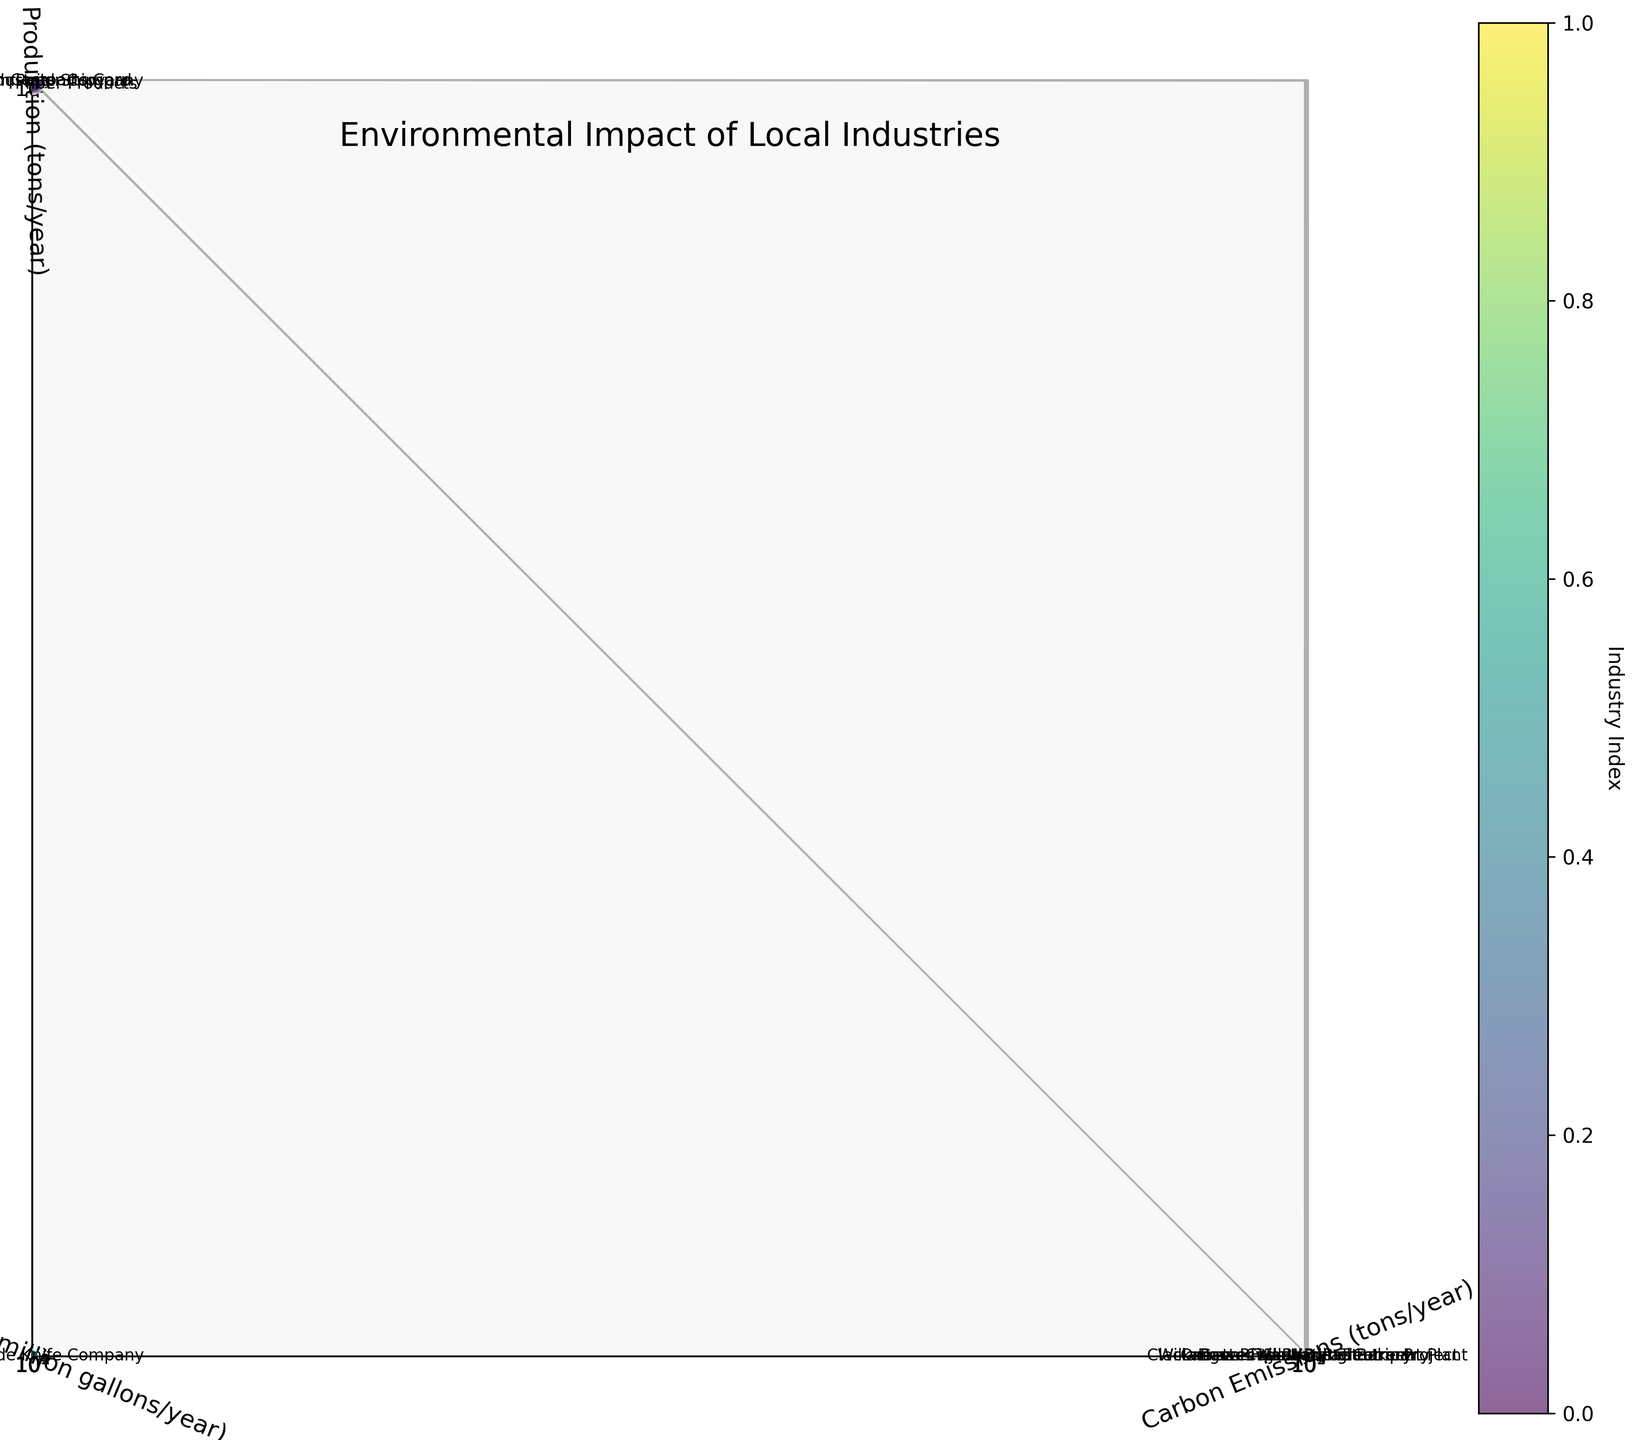What's the title of the figure? The title is typically displayed at the top of the chart. In this case, it is labeled "Environmental Impact of Local Industries," as specified in the code.
Answer: Environmental Impact of Local Industries Which industry has the highest carbon emissions? By examining the x-axis, which represents carbon emissions, and looking for the furthest point to the right, you can identify the industry with the highest carbon emissions. Precision Castparts Corp is found to be the farthest on the x-axis.
Answer: Precision Castparts Corp Which industry uses the most water? By inspecting the y-axis, which represents water usage, and identifying the data point that is highest up along this axis, the label 'Willamette Falls Hydroelectric Project' appears at the highest point.
Answer: Willamette Falls Hydroelectric Project Which industry produces the least waste? To find the industry with the least waste, check the z-axis, representing waste production, and identify the point closest to the bottom. The 'Carver Hangar Restaurant' is the closest to the bottom.
Answer: Carver Hangar Restaurant Which industry has the largest bubble size in the chart? Bubble size in the chart is proportional to (carbon emissions + waste production) / 1000. Visual inspection shows that 'Precision Castparts Corp' has the largest bubble.
Answer: Precision Castparts Corp Compare the water usage between Blue Heron Paper Company and Vigor Industrial Shipyard. Which uses more? Check the y-axis values corresponding to Blue Heron Paper Company and Vigor Industrial Shipyard and compare them. Blue Heron Paper Company uses 1200 million gallons/year, while Vigor Industrial Shipyard uses 600 million gallons/year. Thus, Blue Heron Paper Company uses more water.
Answer: Blue Heron Paper Company How does the carbon emission of Dave's Killer Bread Bakery compare to Estacada Timber Products? Find the points for Dave's Killer Bread Bakery and Estacada Timber Products on the x-axis and compare. Dave's Killer Bread Bakery has 15000 tons/year, and Estacada Timber Products has 40000 tons/year, so Estacada Timber Products has higher emissions.
Answer: Estacada Timber Products What is the average carbon emissions of the industries displayed? Sum all the carbon emissions (75000 + 120000 + 15000 + 5000 + 30000 + 90000 + 10000 + 2000 + 500 + 40000) = 387500. Divide by the number of industries (10), the average is 387500 / 10 = 38750 tons/year.
Answer: 38750 tons/year Which industry has the smallest bubble size in the chart? Bubble size corresponds to (carbon emissions + waste production) / 1000. Therefore, the industry with the smallest bubble has the lowest combined value. 'Carver Hangar Restaurant' seems to have the smallest bubble due to its low values.
Answer: Carver Hangar Restaurant What is the relationship between carbon emissions and waste production for Benchmade Knife Company? Look at the x and z coordinates for Benchmade Knife Company. It has 30000 tons/year of carbon emissions and 12000 tons/year of waste production, indicating that higher carbon emissions are associated with moderate waste production.
Answer: Higher carbon emissions, moderate waste production 